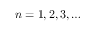<formula> <loc_0><loc_0><loc_500><loc_500>n = 1 , 2 , 3 , \dots</formula> 